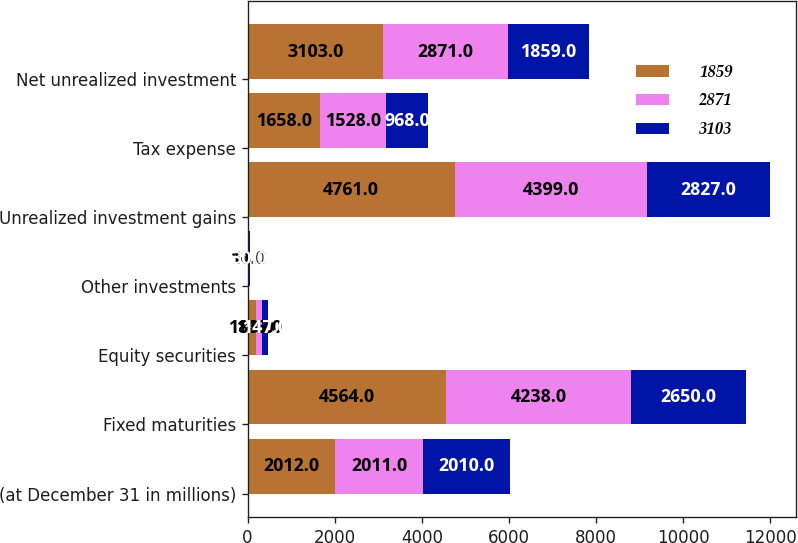Convert chart to OTSL. <chart><loc_0><loc_0><loc_500><loc_500><stacked_bar_chart><ecel><fcel>(at December 31 in millions)<fcel>Fixed maturities<fcel>Equity securities<fcel>Other investments<fcel>Unrealized investment gains<fcel>Tax expense<fcel>Net unrealized investment<nl><fcel>1859<fcel>2012<fcel>4564<fcel>183<fcel>14<fcel>4761<fcel>1658<fcel>3103<nl><fcel>2871<fcel>2011<fcel>4238<fcel>145<fcel>16<fcel>4399<fcel>1528<fcel>2871<nl><fcel>3103<fcel>2010<fcel>2650<fcel>147<fcel>30<fcel>2827<fcel>968<fcel>1859<nl></chart> 